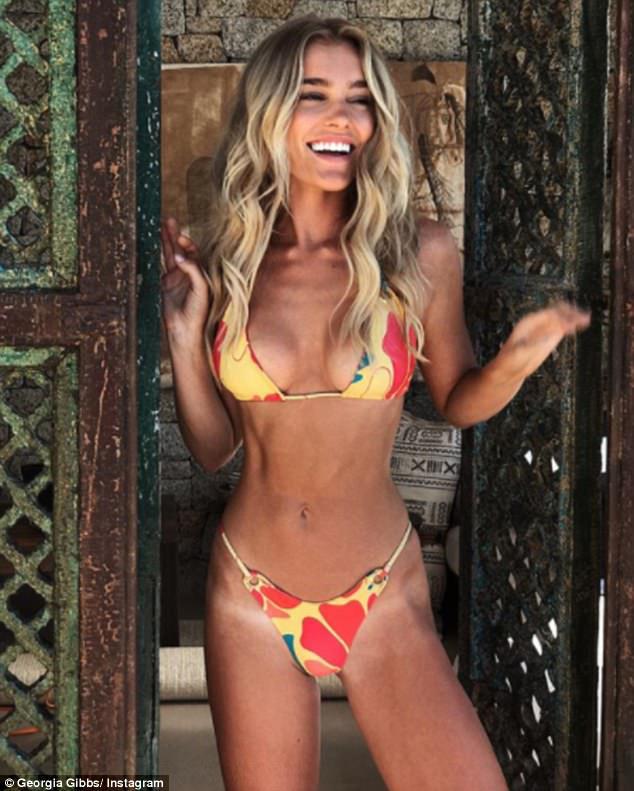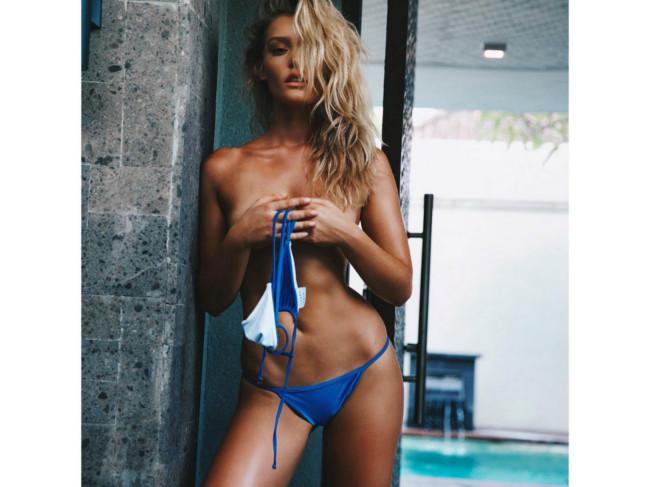The first image is the image on the left, the second image is the image on the right. Analyze the images presented: Is the assertion "A woman is sitting." valid? Answer yes or no. No. 